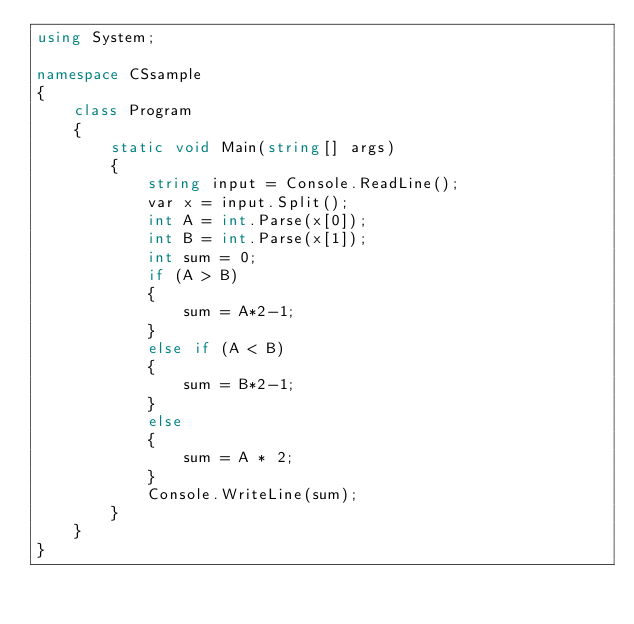Convert code to text. <code><loc_0><loc_0><loc_500><loc_500><_C#_>using System;

namespace CSsample
{
    class Program
    {
        static void Main(string[] args)
        {
            string input = Console.ReadLine();
            var x = input.Split();
            int A = int.Parse(x[0]);
            int B = int.Parse(x[1]);
            int sum = 0;
            if (A > B)
            {
                sum = A*2-1;
            }
            else if (A < B)
            {
                sum = B*2-1;
            }
            else
            {
                sum = A * 2;
            }
            Console.WriteLine(sum);
        }
    }
}

</code> 